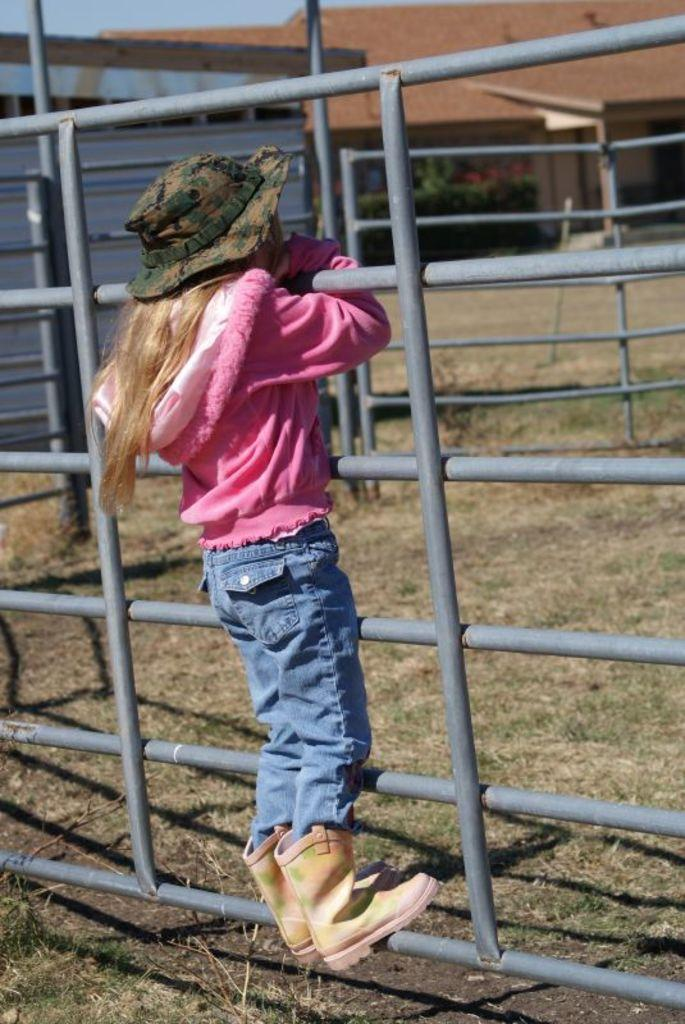Who is the main subject in the image? There is a girl in the image. What is the girl doing in the image? The girl is standing on a rod and holding the support of other rods. What is the ground like below the girl's feet? The ground below the girl's feet is covered with grass. What can be seen in the background of the image? There is a house in the background of the image. Is the girl using a knife to cut the rods in the image? There is no knife present in the image, and the girl is not cutting any rods; she is holding the support of the rods. Can you see any steam coming from the girl's body in the image? There is no steam visible in the image; the girl is simply standing on a rod and holding the support of other rods. 